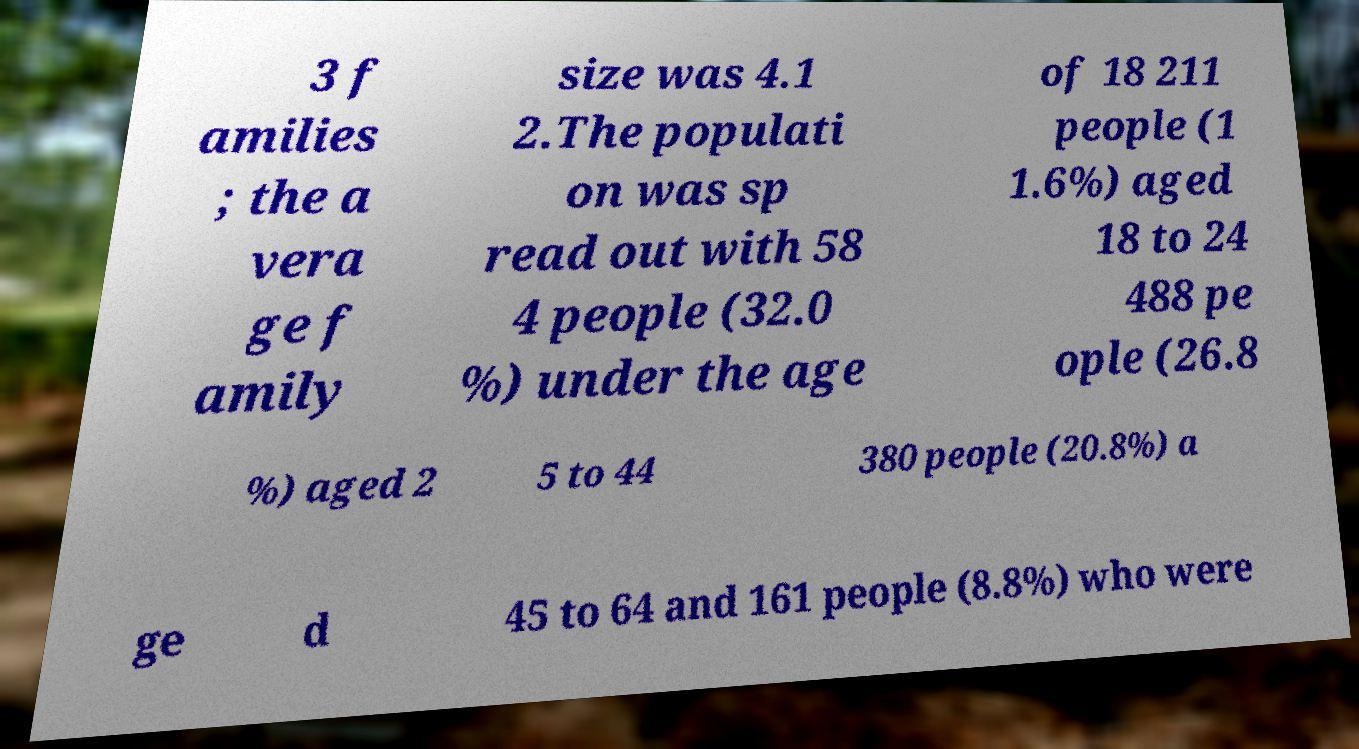Please identify and transcribe the text found in this image. 3 f amilies ; the a vera ge f amily size was 4.1 2.The populati on was sp read out with 58 4 people (32.0 %) under the age of 18 211 people (1 1.6%) aged 18 to 24 488 pe ople (26.8 %) aged 2 5 to 44 380 people (20.8%) a ge d 45 to 64 and 161 people (8.8%) who were 